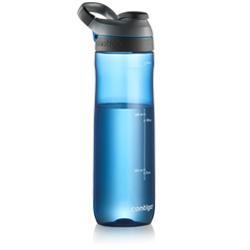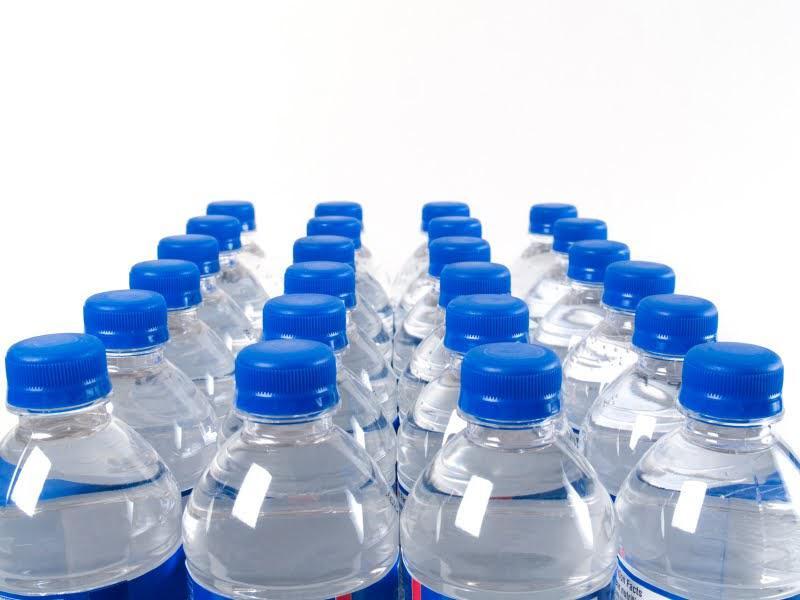The first image is the image on the left, the second image is the image on the right. Evaluate the accuracy of this statement regarding the images: "Some of the containers don't have blue caps.". Is it true? Answer yes or no. Yes. 